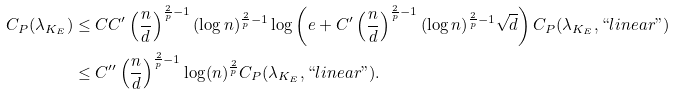Convert formula to latex. <formula><loc_0><loc_0><loc_500><loc_500>C _ { P } ( \lambda _ { K _ { E } } ) & \leq C C ^ { \prime } \left ( \frac { n } { d } \right ) ^ { \frac { 2 } { p } - 1 } ( \log n ) ^ { \frac { 2 } { p } - 1 } \log \left ( e + C ^ { \prime } \left ( \frac { n } { d } \right ) ^ { \frac { 2 } { p } - 1 } ( \log n ) ^ { \frac { 2 } { p } - 1 } \sqrt { d } \right ) C _ { P } ( \lambda _ { K _ { E } } , ` ` l i n e a r " ) \\ & \leq C ^ { \prime \prime } \left ( \frac { n } { d } \right ) ^ { \frac { 2 } { p } - 1 } \log ( n ) ^ { \frac { 2 } { p } } C _ { P } ( \lambda _ { K _ { E } } , ` ` l i n e a r " ) .</formula> 